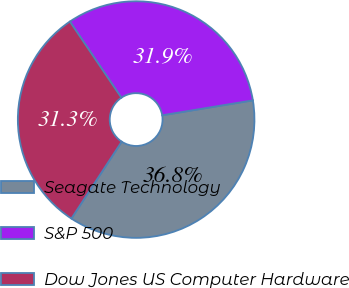Convert chart to OTSL. <chart><loc_0><loc_0><loc_500><loc_500><pie_chart><fcel>Seagate Technology<fcel>S&P 500<fcel>Dow Jones US Computer Hardware<nl><fcel>36.82%<fcel>31.86%<fcel>31.31%<nl></chart> 